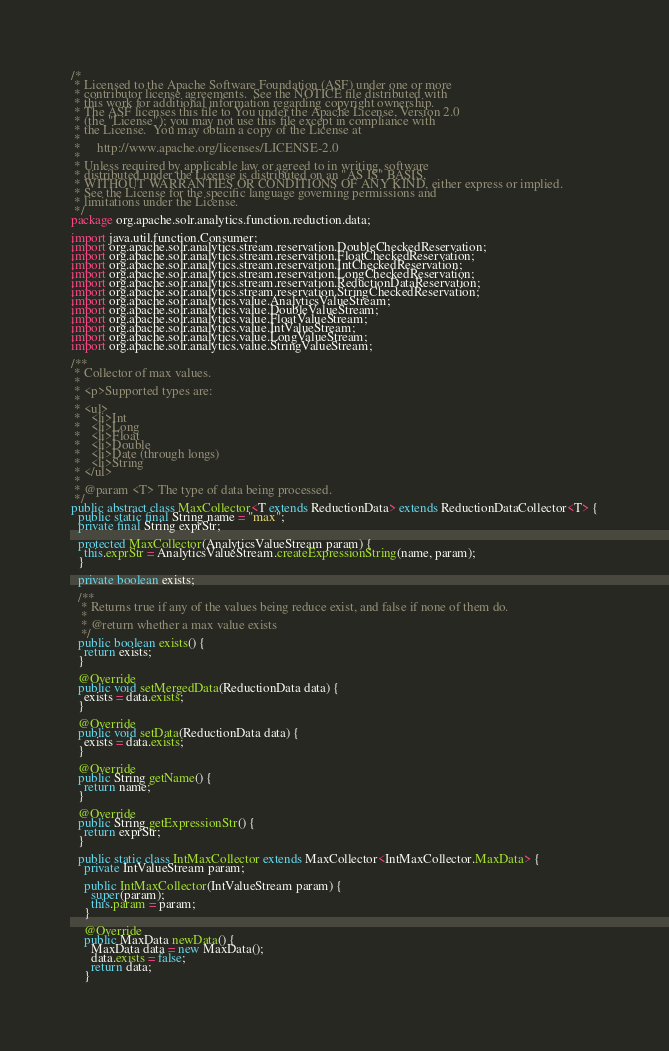Convert code to text. <code><loc_0><loc_0><loc_500><loc_500><_Java_>/*
 * Licensed to the Apache Software Foundation (ASF) under one or more
 * contributor license agreements.  See the NOTICE file distributed with
 * this work for additional information regarding copyright ownership.
 * The ASF licenses this file to You under the Apache License, Version 2.0
 * (the "License"); you may not use this file except in compliance with
 * the License.  You may obtain a copy of the License at
 *
 *     http://www.apache.org/licenses/LICENSE-2.0
 *
 * Unless required by applicable law or agreed to in writing, software
 * distributed under the License is distributed on an "AS IS" BASIS,
 * WITHOUT WARRANTIES OR CONDITIONS OF ANY KIND, either express or implied.
 * See the License for the specific language governing permissions and
 * limitations under the License.
 */
package org.apache.solr.analytics.function.reduction.data;

import java.util.function.Consumer;
import org.apache.solr.analytics.stream.reservation.DoubleCheckedReservation;
import org.apache.solr.analytics.stream.reservation.FloatCheckedReservation;
import org.apache.solr.analytics.stream.reservation.IntCheckedReservation;
import org.apache.solr.analytics.stream.reservation.LongCheckedReservation;
import org.apache.solr.analytics.stream.reservation.ReductionDataReservation;
import org.apache.solr.analytics.stream.reservation.StringCheckedReservation;
import org.apache.solr.analytics.value.AnalyticsValueStream;
import org.apache.solr.analytics.value.DoubleValueStream;
import org.apache.solr.analytics.value.FloatValueStream;
import org.apache.solr.analytics.value.IntValueStream;
import org.apache.solr.analytics.value.LongValueStream;
import org.apache.solr.analytics.value.StringValueStream;

/**
 * Collector of max values.
 *
 * <p>Supported types are:
 *
 * <ul>
 *   <li>Int
 *   <li>Long
 *   <li>Float
 *   <li>Double
 *   <li>Date (through longs)
 *   <li>String
 * </ul>
 *
 * @param <T> The type of data being processed.
 */
public abstract class MaxCollector<T extends ReductionData> extends ReductionDataCollector<T> {
  public static final String name = "max";
  private final String exprStr;

  protected MaxCollector(AnalyticsValueStream param) {
    this.exprStr = AnalyticsValueStream.createExpressionString(name, param);
  }

  private boolean exists;

  /**
   * Returns true if any of the values being reduce exist, and false if none of them do.
   *
   * @return whether a max value exists
   */
  public boolean exists() {
    return exists;
  }

  @Override
  public void setMergedData(ReductionData data) {
    exists = data.exists;
  }

  @Override
  public void setData(ReductionData data) {
    exists = data.exists;
  }

  @Override
  public String getName() {
    return name;
  }

  @Override
  public String getExpressionStr() {
    return exprStr;
  }

  public static class IntMaxCollector extends MaxCollector<IntMaxCollector.MaxData> {
    private IntValueStream param;

    public IntMaxCollector(IntValueStream param) {
      super(param);
      this.param = param;
    }

    @Override
    public MaxData newData() {
      MaxData data = new MaxData();
      data.exists = false;
      return data;
    }
</code> 